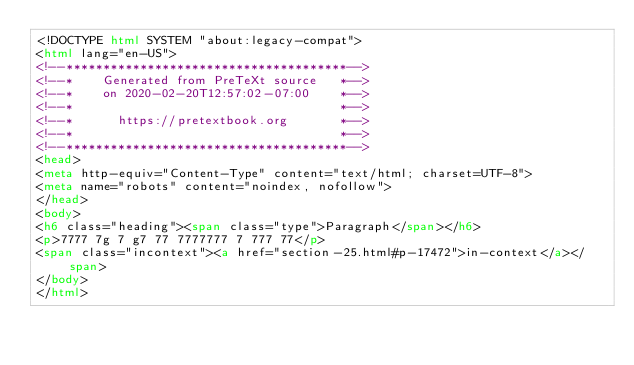Convert code to text. <code><loc_0><loc_0><loc_500><loc_500><_HTML_><!DOCTYPE html SYSTEM "about:legacy-compat">
<html lang="en-US">
<!--**************************************-->
<!--*    Generated from PreTeXt source   *-->
<!--*    on 2020-02-20T12:57:02-07:00    *-->
<!--*                                    *-->
<!--*      https://pretextbook.org       *-->
<!--*                                    *-->
<!--**************************************-->
<head>
<meta http-equiv="Content-Type" content="text/html; charset=UTF-8">
<meta name="robots" content="noindex, nofollow">
</head>
<body>
<h6 class="heading"><span class="type">Paragraph</span></h6>
<p>7777 7g 7 g7 77 7777777 7 777 77</p>
<span class="incontext"><a href="section-25.html#p-17472">in-context</a></span>
</body>
</html>
</code> 